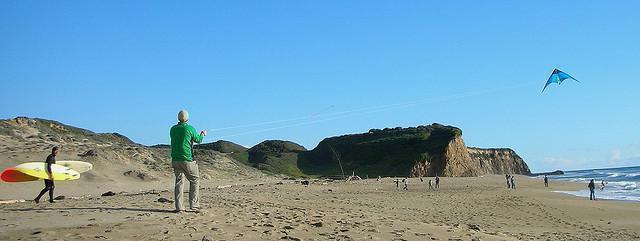What is the man carrying to the water?
Pick the correct solution from the four options below to address the question.
Options: Buckets, blankets, chairs, surfboards. Surfboards. 